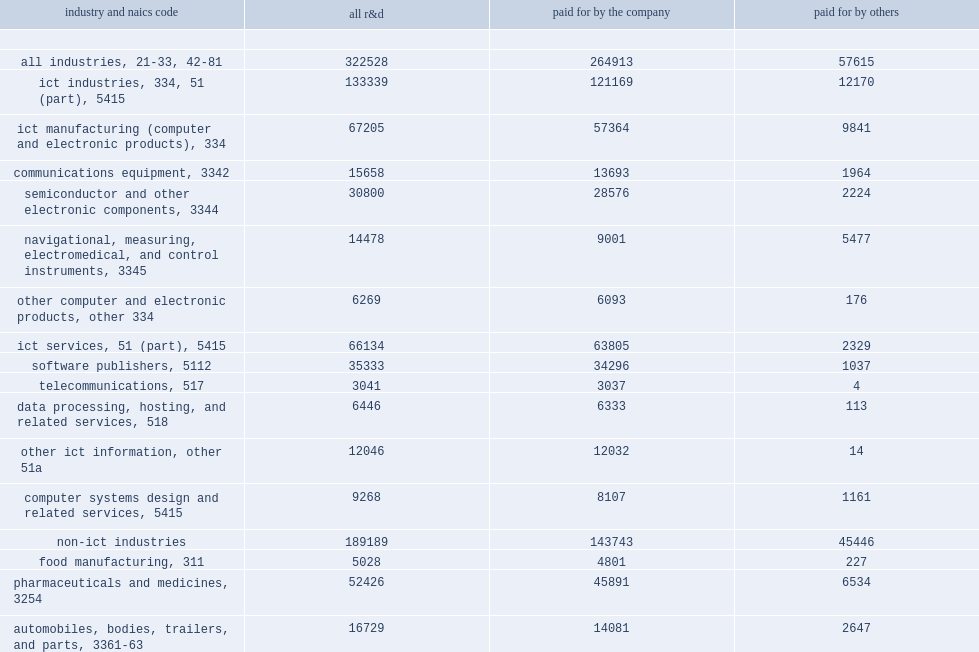How many million dollars of research and development performed by companies in the united states in 2013? 322528.0. Of the $323 billion of research and development performed by companies in the united states in 2013, how many percent did ict industries account for? 0.413418. Of the $323 million of research and development performed by companies in the united states in 2013, how many million dollars did ict industries account for? 133339.0. How many times are r&d expenditures of ict industries larger than the pharmaceutical manufacturing industry, the single largest industry in terms of r&d expenditures in the united states? 2.418857. 